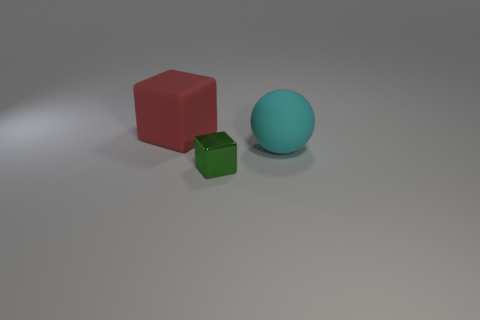Add 1 small purple objects. How many objects exist? 4 Subtract all blocks. How many objects are left? 1 Subtract 0 cyan blocks. How many objects are left? 3 Subtract all red matte cylinders. Subtract all rubber cubes. How many objects are left? 2 Add 2 large cyan rubber things. How many large cyan rubber things are left? 3 Add 3 big cyan rubber things. How many big cyan rubber things exist? 4 